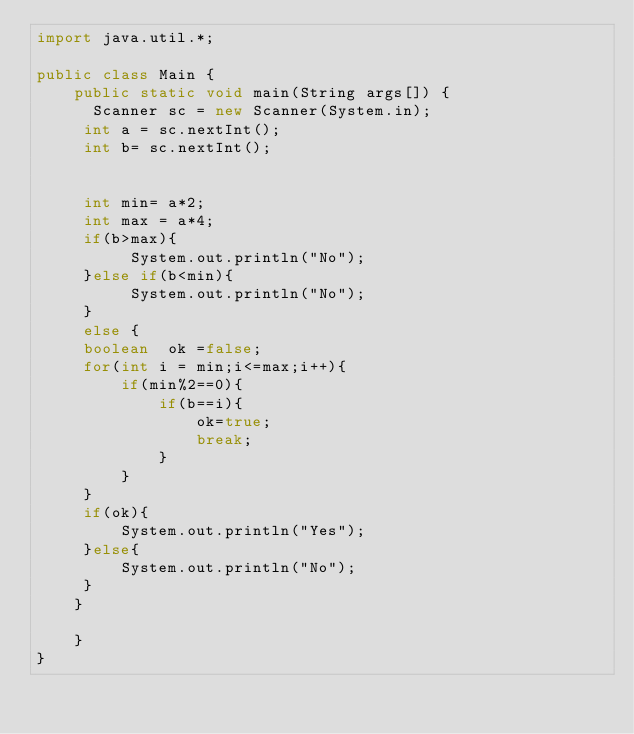<code> <loc_0><loc_0><loc_500><loc_500><_Java_>import java.util.*;

public class Main {
    public static void main(String args[]) {
      Scanner sc = new Scanner(System.in);
     int a = sc.nextInt();
     int b= sc.nextInt();
     
    
     int min= a*2;
     int max = a*4;
     if(b>max){
          System.out.println("No");
     }else if(b<min){
          System.out.println("No");
     }
     else {
     boolean  ok =false;
     for(int i = min;i<=max;i++){
         if(min%2==0){
             if(b==i){
                 ok=true;
                 break;
             }
         }
     }
     if(ok){
         System.out.println("Yes");
     }else{
         System.out.println("No");
     }
    }
        
    }
}</code> 